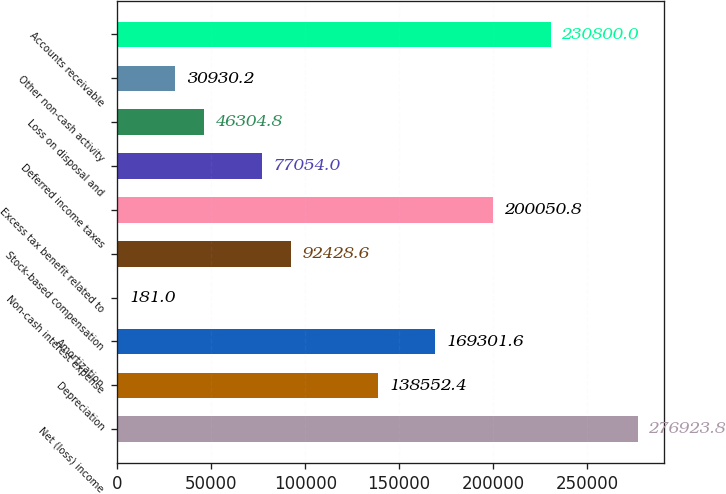Convert chart. <chart><loc_0><loc_0><loc_500><loc_500><bar_chart><fcel>Net (loss) income<fcel>Depreciation<fcel>Amortization<fcel>Non-cash interest expense<fcel>Stock-based compensation<fcel>Excess tax benefit related to<fcel>Deferred income taxes<fcel>Loss on disposal and<fcel>Other non-cash activity<fcel>Accounts receivable<nl><fcel>276924<fcel>138552<fcel>169302<fcel>181<fcel>92428.6<fcel>200051<fcel>77054<fcel>46304.8<fcel>30930.2<fcel>230800<nl></chart> 